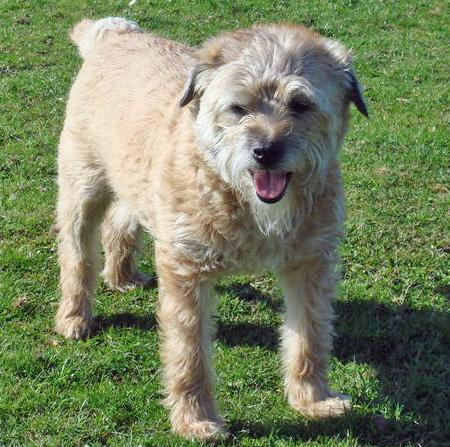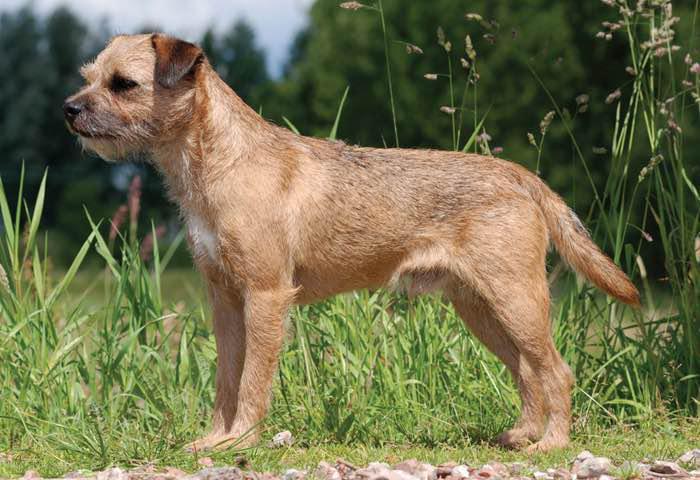The first image is the image on the left, the second image is the image on the right. Considering the images on both sides, is "An image contains a small dog with water in the background." valid? Answer yes or no. No. The first image is the image on the left, the second image is the image on the right. Examine the images to the left and right. Is the description "At least one image shows a body of water behind one dog." accurate? Answer yes or no. No. 